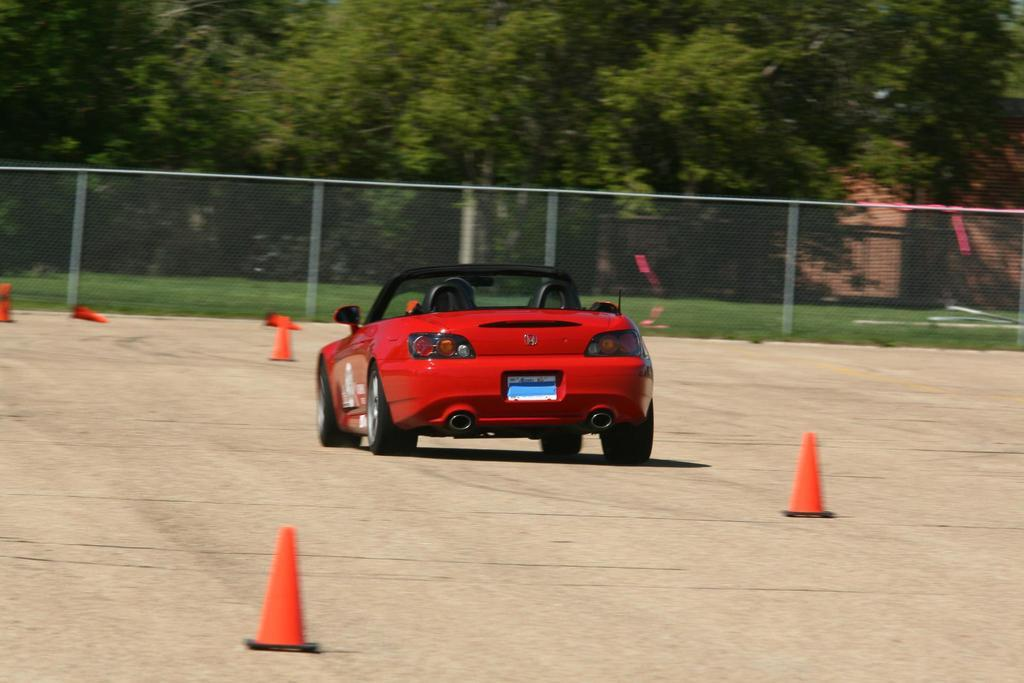What type of vehicle is in the image? There is a vehicle in the image, but the specific type is not mentioned. What colors can be seen on the vehicle? The vehicle is red and black in color. What safety feature is present in the image? There are road cones in the image. What type of surface is visible in the image? There is a road in the image. What type of barrier is present in the image? There is a fence in the image. What type of vegetation is present in the image? There is grass and trees in the image. Can you see a squirrel wearing a mask in the image? There is no squirrel or mask present in the image. 